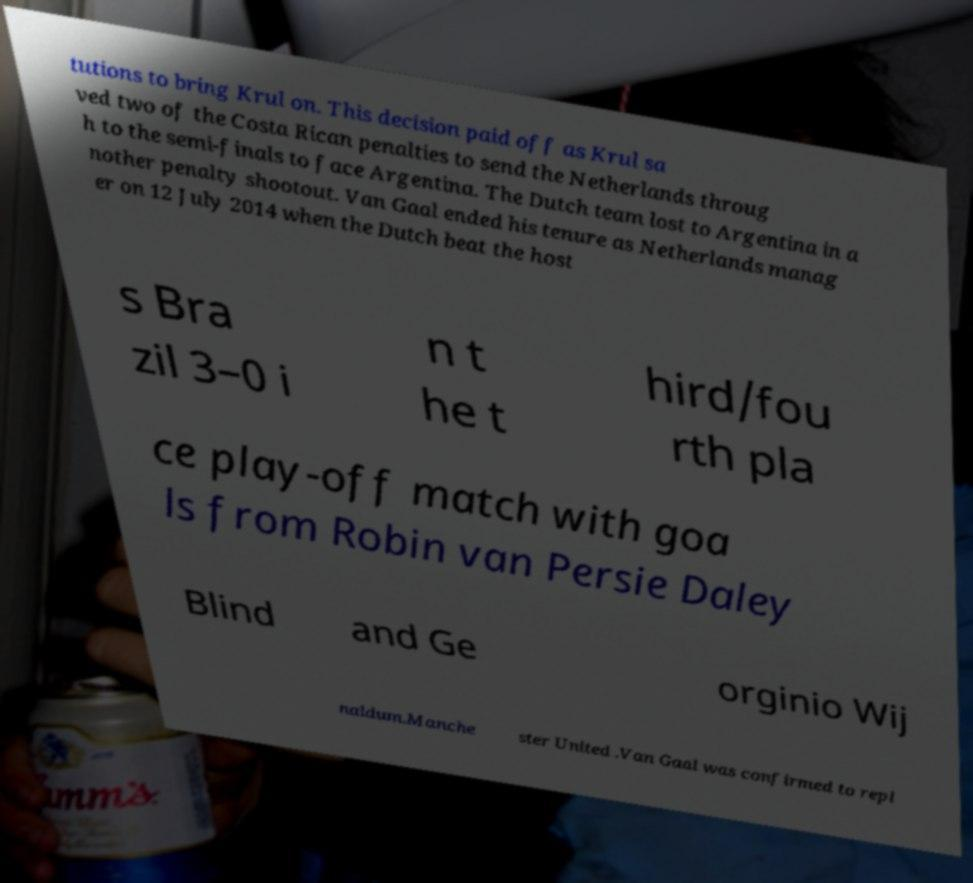There's text embedded in this image that I need extracted. Can you transcribe it verbatim? tutions to bring Krul on. This decision paid off as Krul sa ved two of the Costa Rican penalties to send the Netherlands throug h to the semi-finals to face Argentina. The Dutch team lost to Argentina in a nother penalty shootout. Van Gaal ended his tenure as Netherlands manag er on 12 July 2014 when the Dutch beat the host s Bra zil 3–0 i n t he t hird/fou rth pla ce play-off match with goa ls from Robin van Persie Daley Blind and Ge orginio Wij naldum.Manche ster United .Van Gaal was confirmed to repl 